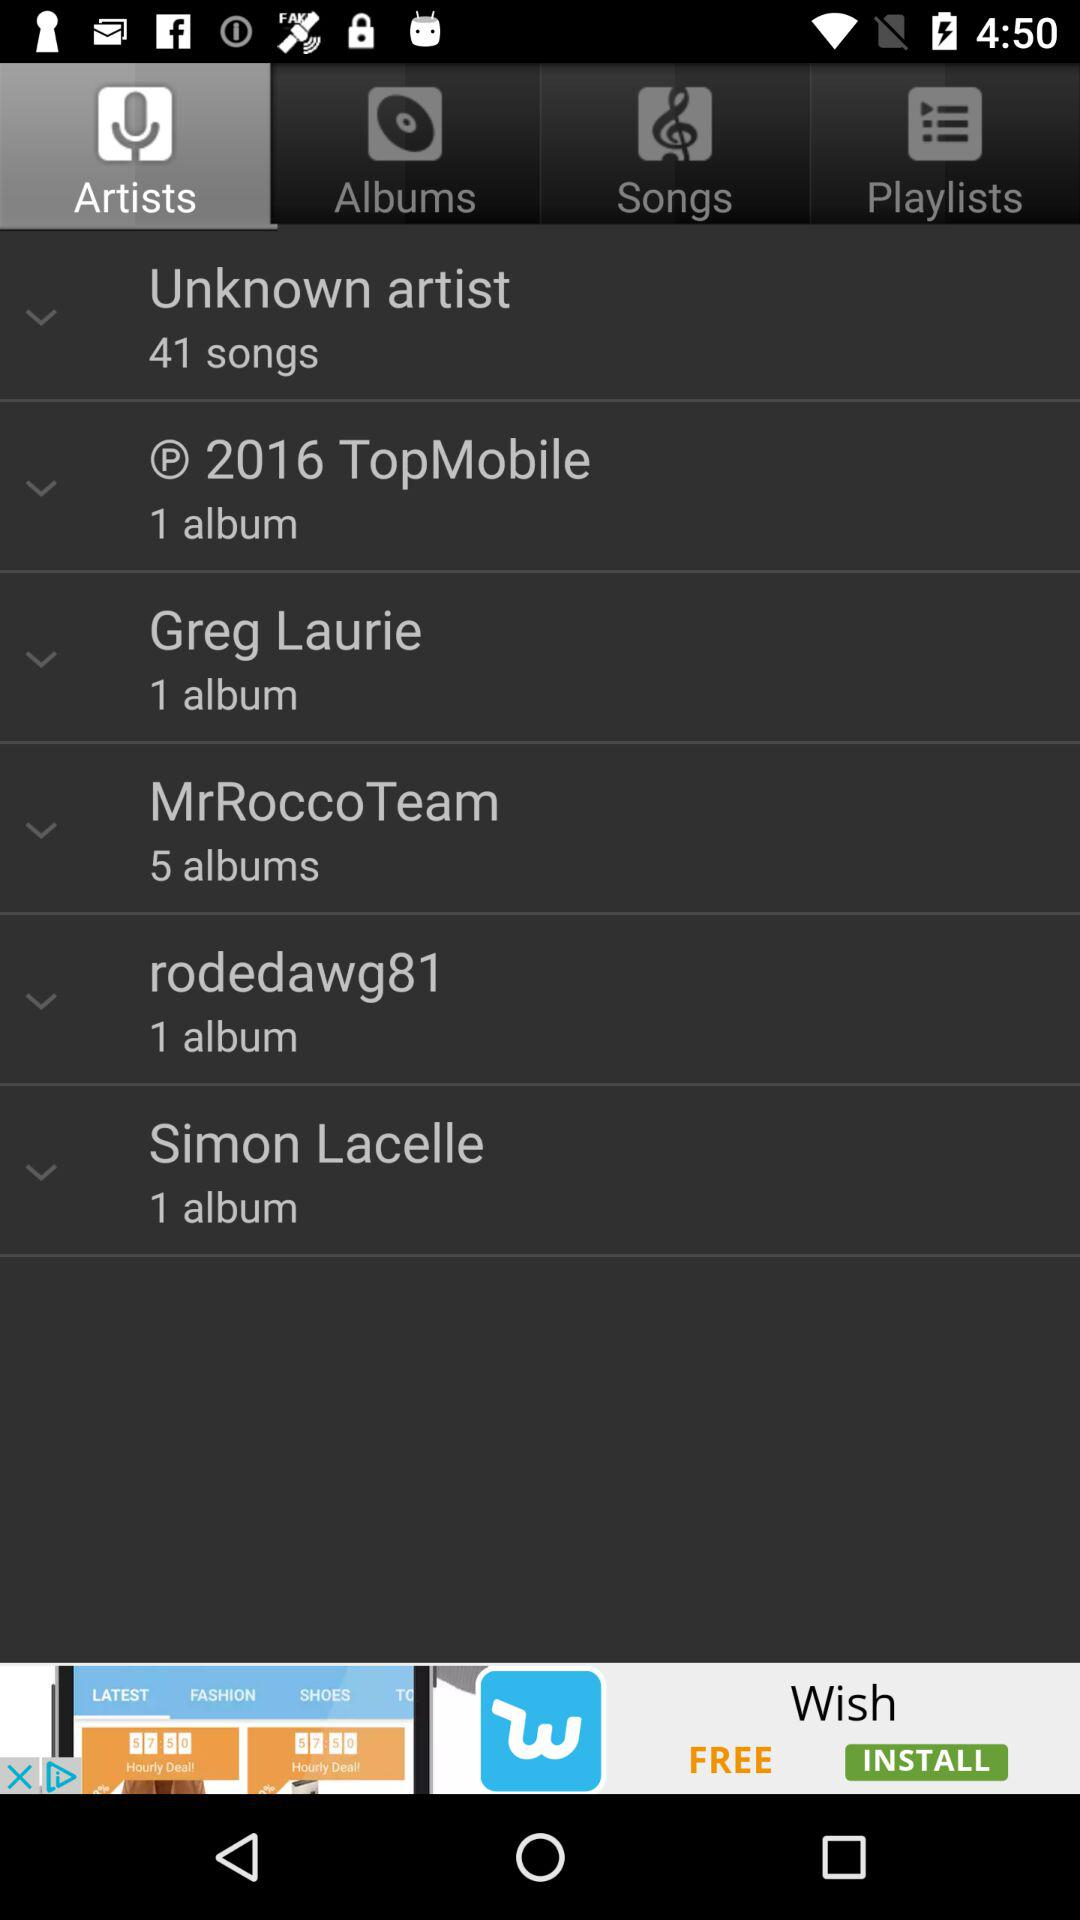How many albums are there by Greg Laurie? There is 1 album by Greg Laurie. 